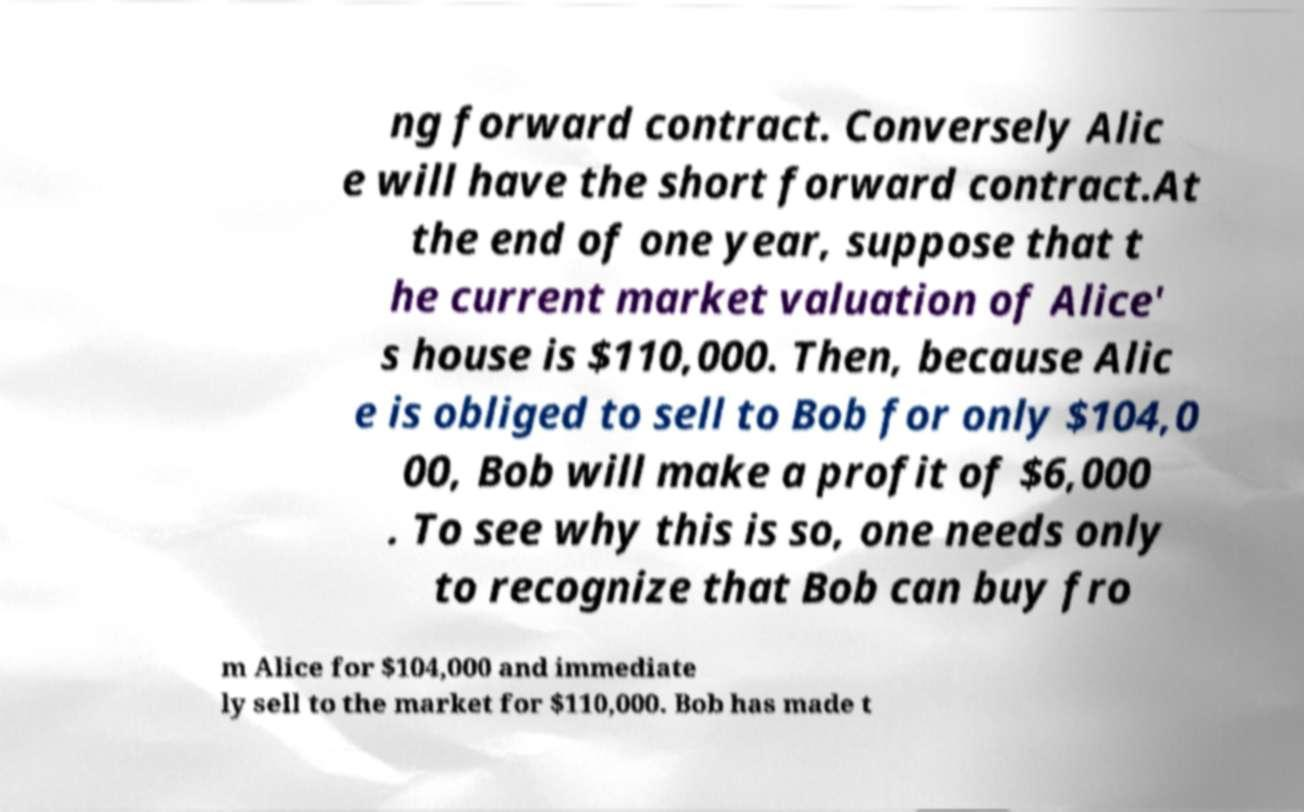Can you read and provide the text displayed in the image?This photo seems to have some interesting text. Can you extract and type it out for me? ng forward contract. Conversely Alic e will have the short forward contract.At the end of one year, suppose that t he current market valuation of Alice' s house is $110,000. Then, because Alic e is obliged to sell to Bob for only $104,0 00, Bob will make a profit of $6,000 . To see why this is so, one needs only to recognize that Bob can buy fro m Alice for $104,000 and immediate ly sell to the market for $110,000. Bob has made t 